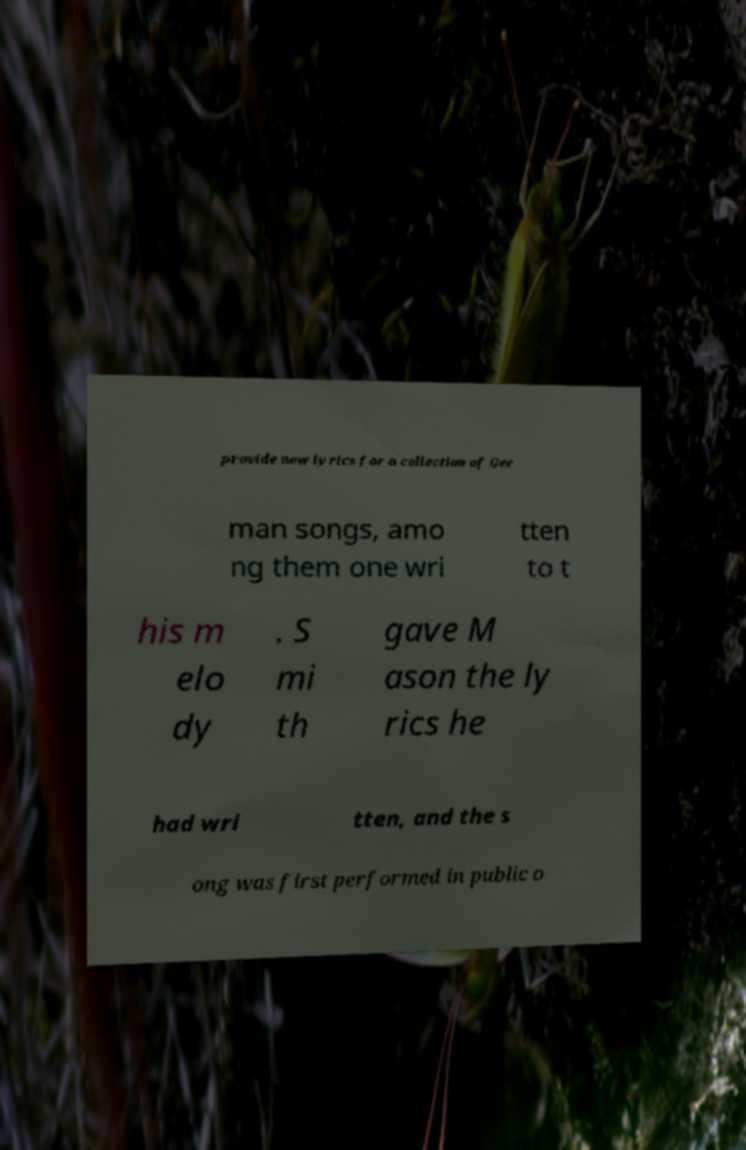Please identify and transcribe the text found in this image. provide new lyrics for a collection of Ger man songs, amo ng them one wri tten to t his m elo dy . S mi th gave M ason the ly rics he had wri tten, and the s ong was first performed in public o 